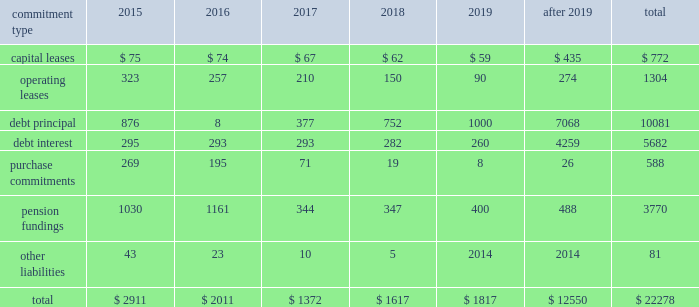United parcel service , inc .
And subsidiaries management's discussion and analysis of financial condition and results of operations issuances of debt in 2014 and 2013 consisted primarily of longer-maturity commercial paper .
Issuances of debt in 2012 consisted primarily of senior fixed rate note offerings totaling $ 1.75 billion .
Repayments of debt in 2014 and 2013 consisted primarily of the maturity of our $ 1.0 and $ 1.75 billion senior fixed rate notes that matured in april 2014 and january 2013 , respectively .
The remaining repayments of debt during the 2012 through 2014 time period included paydowns of commercial paper and scheduled principal payments on our capitalized lease obligations .
We consider the overall fixed and floating interest rate mix of our portfolio and the related overall cost of borrowing when planning for future issuances and non-scheduled repayments of debt .
We had $ 772 million of commercial paper outstanding at december 31 , 2014 , and no commercial paper outstanding at december 31 , 2013 and 2012 .
The amount of commercial paper outstanding fluctuates throughout each year based on daily liquidity needs .
The average commercial paper balance was $ 1.356 billion and the average interest rate paid was 0.10% ( 0.10 % ) in 2014 ( $ 1.013 billion and 0.07% ( 0.07 % ) in 2013 , and $ 962 million and 0.07% ( 0.07 % ) in 2012 , respectively ) .
The variation in cash received from common stock issuances to employees was primarily due to level of stock option exercises in the 2012 through 2014 period .
The cash outflows in other financing activities were impacted by several factors .
Cash inflows ( outflows ) from the premium payments and settlements of capped call options for the purchase of ups class b shares were $ ( 47 ) , $ ( 93 ) and $ 206 million for 2014 , 2013 and 2012 , respectively .
Cash outflows related to the repurchase of shares to satisfy tax withholding obligations on vested employee stock awards were $ 224 , $ 253 and $ 234 million for 2014 , 2013 and 2012 , respectively .
In 2013 , we paid $ 70 million to purchase the noncontrolling interest in a joint venture that operates in the middle east , turkey and portions of the central asia region .
In 2012 , we settled several interest rate derivatives that were designated as hedges of the senior fixed-rate debt offerings that year , which resulted in a cash outflow of $ 70 million .
Sources of credit see note 7 to the audited consolidated financial statements for a discussion of our available credit and debt covenants .
Guarantees and other off-balance sheet arrangements we do not have guarantees or other off-balance sheet financing arrangements , including variable interest entities , which we believe could have a material impact on financial condition or liquidity .
Contractual commitments we have contractual obligations and commitments in the form of capital leases , operating leases , debt obligations , purchase commitments , and certain other liabilities .
We intend to satisfy these obligations through the use of cash flow from operations .
The table summarizes the expected cash outflow to satisfy our contractual obligations and commitments as of december 31 , 2014 ( in millions ) : .

What portion of the total contractual obligations is related to the repayment of debt principal? 
Computations: (10081 / 22278)
Answer: 0.45251. 